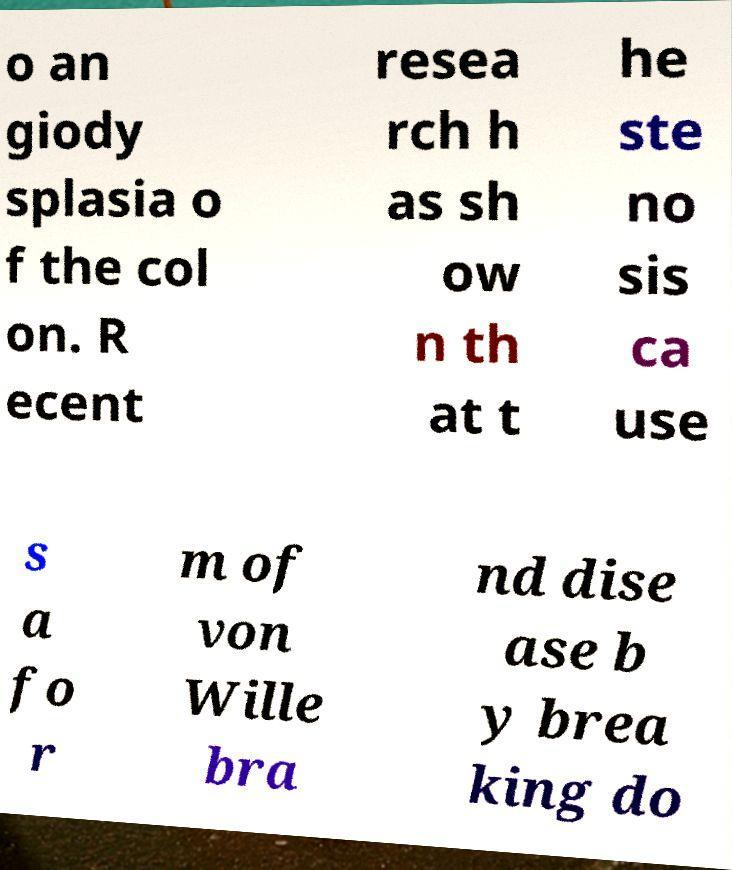There's text embedded in this image that I need extracted. Can you transcribe it verbatim? o an giody splasia o f the col on. R ecent resea rch h as sh ow n th at t he ste no sis ca use s a fo r m of von Wille bra nd dise ase b y brea king do 